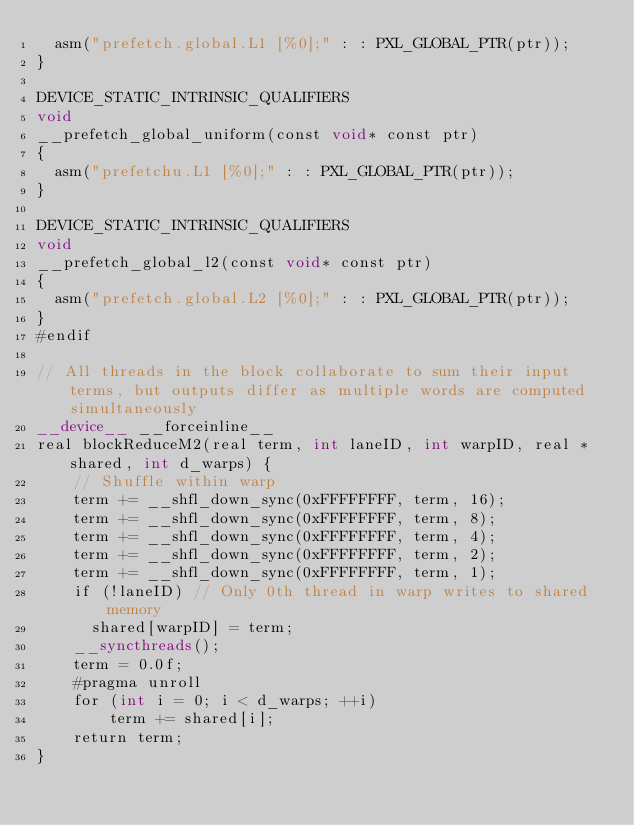Convert code to text. <code><loc_0><loc_0><loc_500><loc_500><_Cuda_>  asm("prefetch.global.L1 [%0];" : : PXL_GLOBAL_PTR(ptr));
}

DEVICE_STATIC_INTRINSIC_QUALIFIERS
void
__prefetch_global_uniform(const void* const ptr)
{
  asm("prefetchu.L1 [%0];" : : PXL_GLOBAL_PTR(ptr));
}

DEVICE_STATIC_INTRINSIC_QUALIFIERS
void
__prefetch_global_l2(const void* const ptr)
{
  asm("prefetch.global.L2 [%0];" : : PXL_GLOBAL_PTR(ptr));
}
#endif

// All threads in the block collaborate to sum their input terms, but outputs differ as multiple words are computed simultaneously
__device__ __forceinline__
real blockReduceM2(real term, int laneID, int warpID, real *shared, int d_warps) {
    // Shuffle within warp
    term += __shfl_down_sync(0xFFFFFFFF, term, 16);
    term += __shfl_down_sync(0xFFFFFFFF, term, 8);
    term += __shfl_down_sync(0xFFFFFFFF, term, 4);
    term += __shfl_down_sync(0xFFFFFFFF, term, 2);
    term += __shfl_down_sync(0xFFFFFFFF, term, 1);
    if (!laneID) // Only 0th thread in warp writes to shared memory
      shared[warpID] = term;
    __syncthreads();
    term = 0.0f;
    #pragma unroll
    for (int i = 0; i < d_warps; ++i)
        term += shared[i];
    return term;
}
</code> 